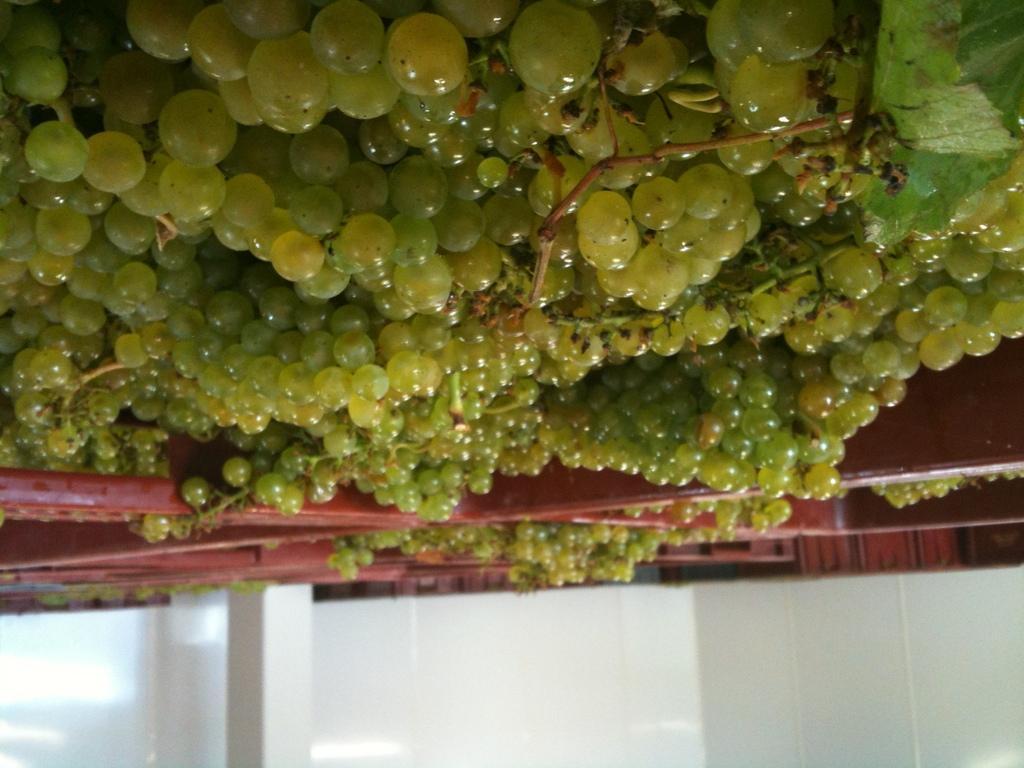Could you give a brief overview of what you see in this image? In this picture we can see the wall and a pillar and in the background we can see a group of grapes. 